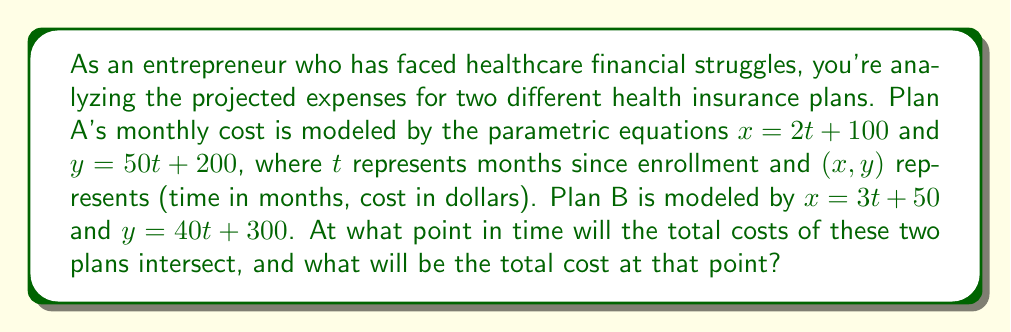Can you answer this question? To solve this problem, we need to find the point where the two parametric equations intersect. This means we need to find values of $t_A$ and $t_B$ (for Plans A and B respectively) where both $x$ and $y$ coordinates are equal.

1) First, let's equate the $x$ coordinates:
   $2t_A + 100 = 3t_B + 50$

2) Now, let's equate the $y$ coordinates:
   $50t_A + 200 = 40t_B + 300$

3) From the first equation, we can express $t_A$ in terms of $t_B$:
   $2t_A + 100 = 3t_B + 50$
   $2t_A = 3t_B - 50$
   $t_A = \frac{3t_B - 50}{2}$

4) Substitute this into the second equation:
   $50(\frac{3t_B - 50}{2}) + 200 = 40t_B + 300$

5) Simplify:
   $75t_B - 1250 + 200 = 40t_B + 300$
   $75t_B - 1050 = 40t_B + 300$
   $35t_B = 1350$
   $t_B = \frac{1350}{35} = 38.57$

6) Now we can find $t_A$:
   $t_A = \frac{3(38.57) - 50}{2} = 38.57$

7) The fact that $t_A = t_B$ confirms that we've found the intersection point.

8) To find the $x$ coordinate (time in months), we can use either equation:
   $x = 2(38.57) + 100 = 177.14$ months

9) To find the $y$ coordinate (total cost in dollars), we can use either equation:
   $y = 50(38.57) + 200 = 2128.50$ dollars

Therefore, the two plans will intersect after approximately 177.14 months (about 14 years and 9 months) at a total cost of $2128.50.
Answer: The two healthcare expense trajectories intersect after approximately 177.14 months at a total cost of $2128.50. 